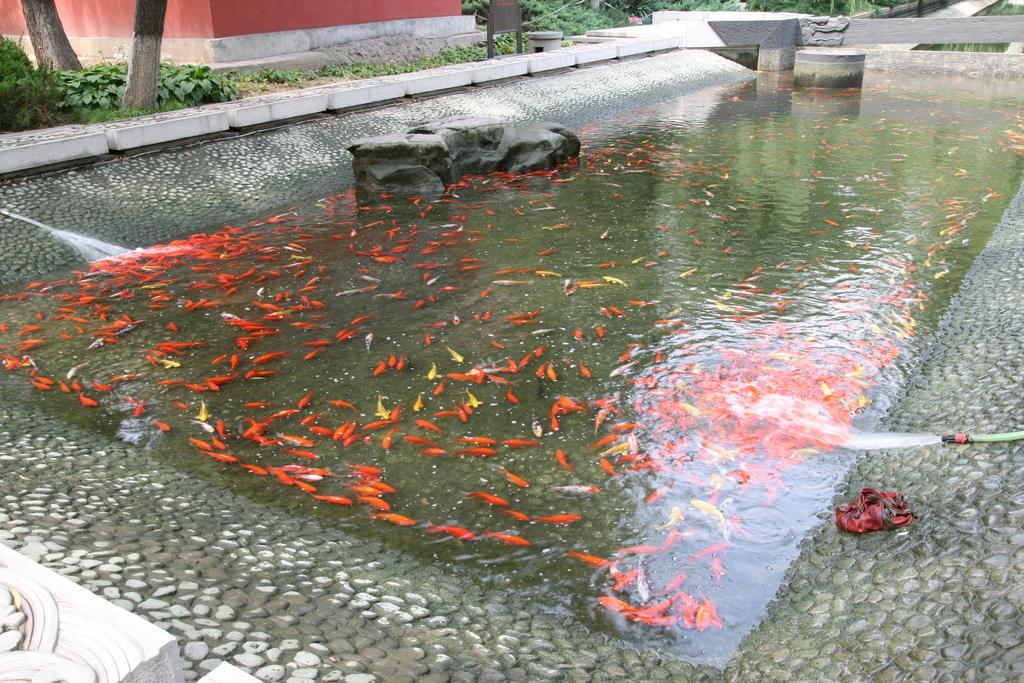In one or two sentences, can you explain what this image depicts? In this image we can see a pool in which there are some fishes, there are two water pipes from which water is flowing into the pool and in the background of the image there are some trees and house. 